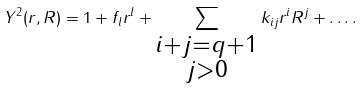Convert formula to latex. <formula><loc_0><loc_0><loc_500><loc_500>Y ^ { 2 } ( r , R ) = 1 + f _ { l } r ^ { l } + \sum _ { \substack { i + j = q + 1 \\ j > 0 } } k _ { i j } r ^ { i } R ^ { j } + \dots .</formula> 